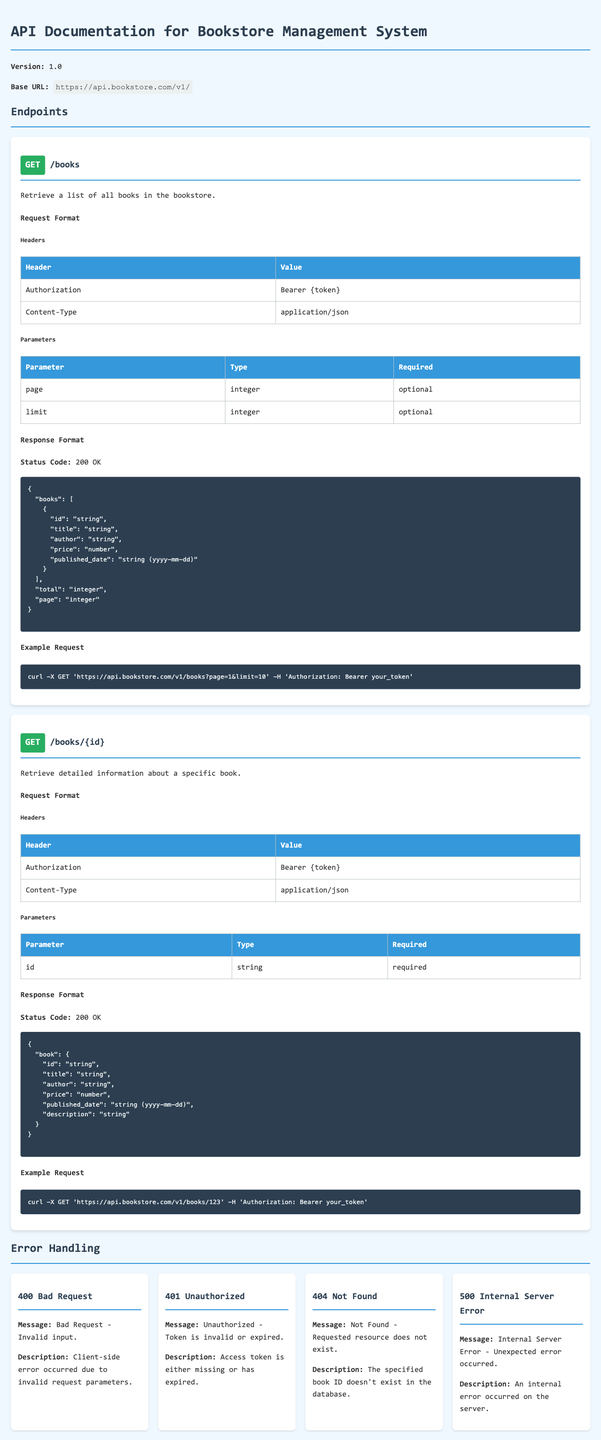What is the base URL for the API? The base URL is stated within the document to provide information on where the API can be accessed.
Answer: https://api.bookstore.com/v1/ How many error codes are defined in the Error Handling section? The document lists distinct error codes and provides descriptions for each, allowing us to count them.
Answer: 4 What HTTP method is used to retrieve a list of all books? The method for accessing the books endpoint is specified in the Method section of the document.
Answer: GET What is the expected response status code for a successful request to retrieve a specific book? The document identifies the status code for a successful response to this specific endpoint, reflecting standard API practices.
Answer: 200 OK Is the "page" parameter required for the /books endpoint? The requirements for the parameters are outlined in a table, indicating whether they are mandatory or optional.
Answer: optional What error message corresponds to a 404 status code? The document contains details regarding the error handling, including specific messages associated with each status code.
Answer: Not Found - Requested resource does not exist What type should the "id" parameter be for the /books/{id} endpoint? The expected data type for the parameter is provided in the Parameters section for that endpoint.
Answer: string What is the version of the API documentation? The version number is presented prominently at the beginning of the document for easy reference.
Answer: 1.0 